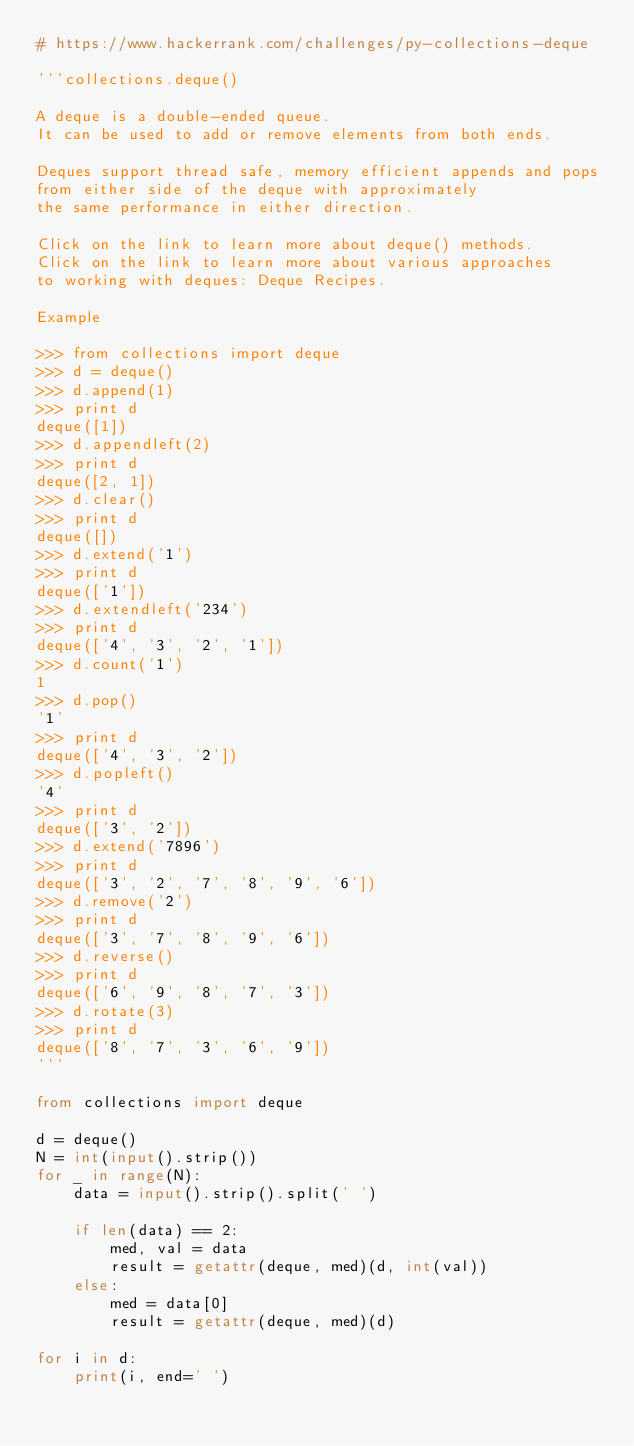<code> <loc_0><loc_0><loc_500><loc_500><_Python_># https://www.hackerrank.com/challenges/py-collections-deque

'''collections.deque()

A deque is a double-ended queue.
It can be used to add or remove elements from both ends.

Deques support thread safe, memory efficient appends and pops
from either side of the deque with approximately
the same performance in either direction.

Click on the link to learn more about deque() methods.
Click on the link to learn more about various approaches
to working with deques: Deque Recipes.

Example

>>> from collections import deque
>>> d = deque()
>>> d.append(1)
>>> print d
deque([1])
>>> d.appendleft(2)
>>> print d
deque([2, 1])
>>> d.clear()
>>> print d
deque([])
>>> d.extend('1')
>>> print d
deque(['1'])
>>> d.extendleft('234')
>>> print d
deque(['4', '3', '2', '1'])
>>> d.count('1')
1
>>> d.pop()
'1'
>>> print d
deque(['4', '3', '2'])
>>> d.popleft()
'4'
>>> print d
deque(['3', '2'])
>>> d.extend('7896')
>>> print d
deque(['3', '2', '7', '8', '9', '6'])
>>> d.remove('2')
>>> print d
deque(['3', '7', '8', '9', '6'])
>>> d.reverse()
>>> print d
deque(['6', '9', '8', '7', '3'])
>>> d.rotate(3)
>>> print d
deque(['8', '7', '3', '6', '9'])
'''

from collections import deque

d = deque()
N = int(input().strip())
for _ in range(N):
    data = input().strip().split(' ')

    if len(data) == 2:
        med, val = data
        result = getattr(deque, med)(d, int(val))
    else:
        med = data[0]
        result = getattr(deque, med)(d)

for i in d:
    print(i, end=' ')
</code> 